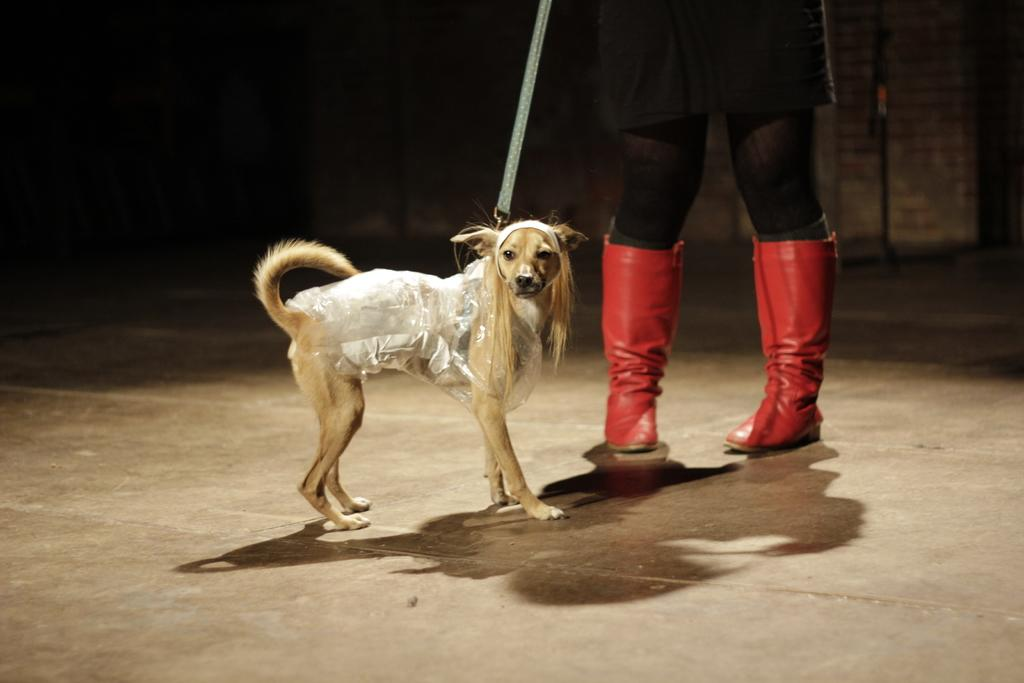What is the main subject of the image? There is a human in the image. What is the human doing in the image? The human is holding a dog. How is the dog connected to the human? The dog is attached to the human with a string. What is covering the dog in the image? There is a polythene cover on the dog. What can be observed about the lighting in the image? The background of the image is dark. Can you see a house in the background of the image? There is no house visible in the image; the background is dark. Is there a volleyball being played in the image? There is no volleyball or any indication of a game being played in the image. Is there a fight happening between the human and the dog in the image? There is no fight depicted in the image; the human is holding the dog with a string. 